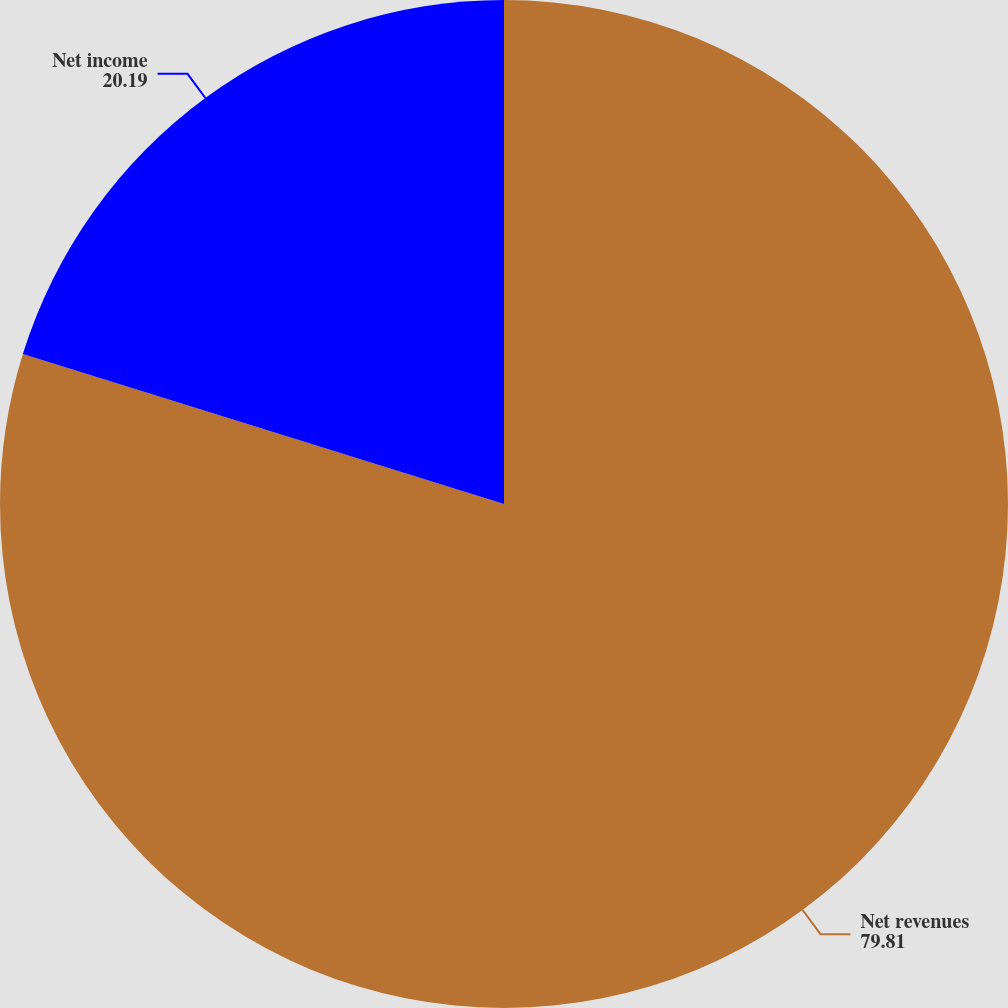<chart> <loc_0><loc_0><loc_500><loc_500><pie_chart><fcel>Net revenues<fcel>Net income<nl><fcel>79.81%<fcel>20.19%<nl></chart> 